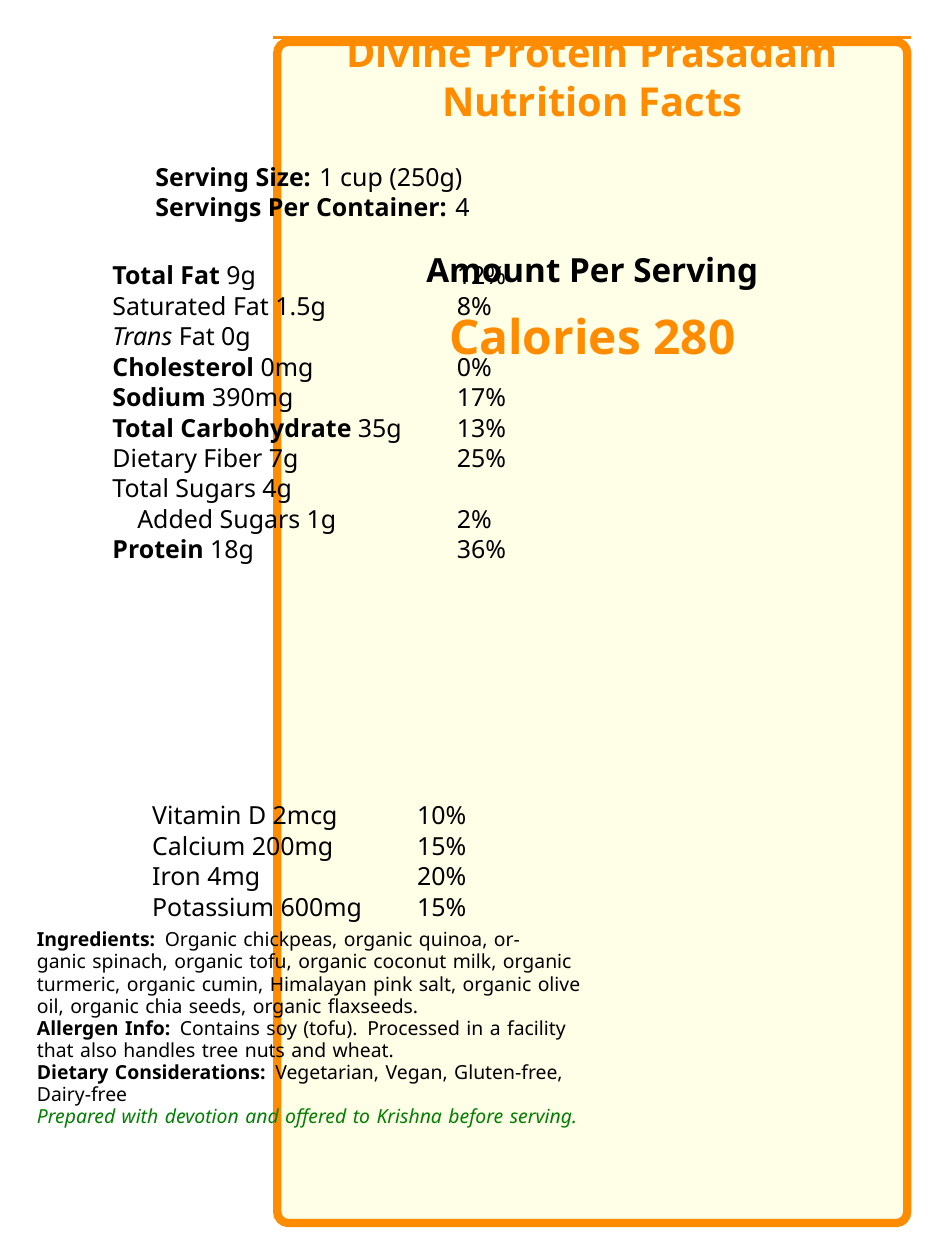What is the serving size of Divine Protein Prasadam? The serving size is indicated as "1 cup (250g)" in the document.
Answer: 1 cup (250g) How many servings are there per container? The document states that there are 4 servings per container.
Answer: 4 What is the total fat content per serving? The total fat content per serving is listed as 9g.
Answer: 9g How much protein is in one serving? The amount of protein per serving is given as 18g.
Answer: 18g What is the calorie content per serving? The document specifies that there are 280 calories per serving.
Answer: 280 calories Which of the following is NOT an ingredient in Divine Protein Prasadam? A) Organic chickpeas B) Organic kale C) Organic tofu D) Organic quinoa The document lists the ingredients, and organic kale is not one of them.
Answer: B) Organic kale How much dietary fiber does one serving contain? The dietary fiber content per serving is shown to be 7g.
Answer: 7g Does Divine Protein Prasadam contain any added sugars? The document indicates that there are 1g of added sugars per serving.
Answer: Yes Which nutrient has the highest daily value percentage per serving? A) Vitamin D B) Calcium C) Iron D) Protein Protein has a daily value percentage of 36%, which is the highest among the listed nutrients.
Answer: D) Protein Is Divine Protein Prasadam dairy-free? The dietary considerations section states that it is dairy-free.
Answer: Yes How much sodium is there in one serving? The sodium content per serving is recorded as 390mg.
Answer: 390mg Can the Divine Protein Prasadam be considered vegan? According to the dietary considerations, it is vegan.
Answer: Yes What is the storage instruction for Divine Protein Prasadam? The storage instructions are explicitly stated in the document.
Answer: Keep refrigerated. Consume within 3 days of preparation. What is the daily value percentage of iron per serving? The document indicates that one serving provides 20% of the daily value for iron.
Answer: 20% How is the prasadam prepared spiritually before serving? The spiritual notes section mentions that it is prepared with devotion and offered to Krishna before serving.
Answer: Prepared with devotion and offered to Krishna before serving. What is the main allergen listed for this product? The allergen information mentions that this product contains soy (tofu).
Answer: Soy (tofu) Summarize the nutrition and dietary information of Divine Protein Prasadam in two sentences. The summary covers the main nutritional information and key dietary considerations mentioned in the document.
Answer: Divine Protein Prasadam is a high-protein, vegetarian, vegan, gluten-free, dairy-free meal with significant amounts of nutrients such as protein (18g), dietary fiber (7g), and iron (20% DV). It contains 280 calories, 9g of total fat, and is prepared with devotion and offered to Krishna. Can the document tell us where the ingredients were sourced? The document lists the ingredients but does not provide information on the sourcing location of the ingredients.
Answer: Not enough information How many calories would you consume if you ate 2 servings? Each serving contains 280 calories, so 2 servings would amount to 280 calories/serving * 2 servings = 560 calories.
Answer: 560 calories 